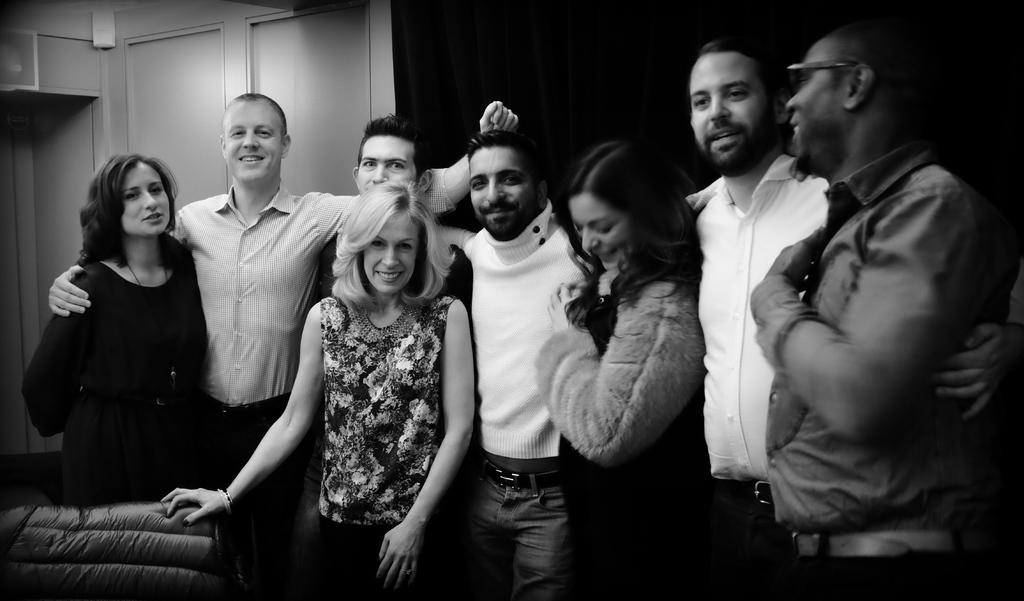What is the color scheme of the image? The image is black and white. What can be seen in the image? There is a group of people in the image. What are the people in the image doing? The people are standing and posing for a photo. What is visible in the background of the image? There is a curtain in the background of the image. What type of base is supporting the vacation in the image? There is no mention of a vacation or a base in the image; it features a group of people posing for a photo in a black and white setting. 